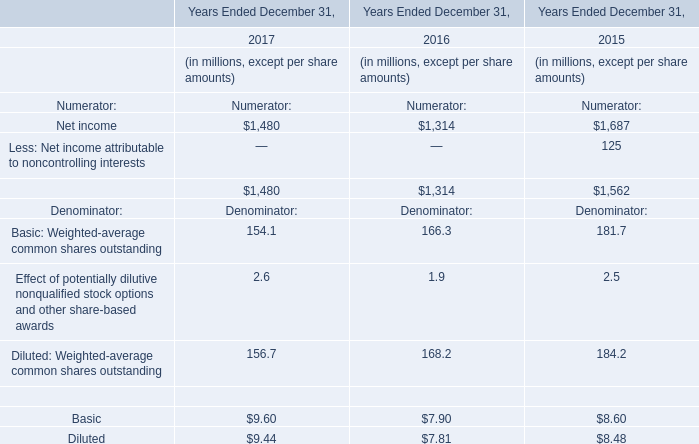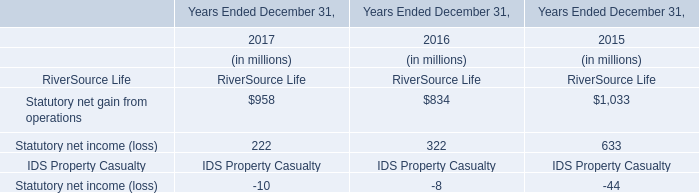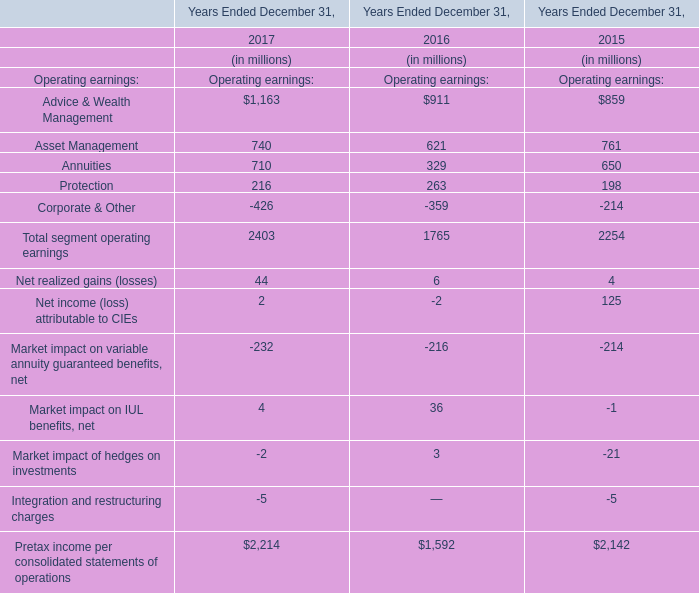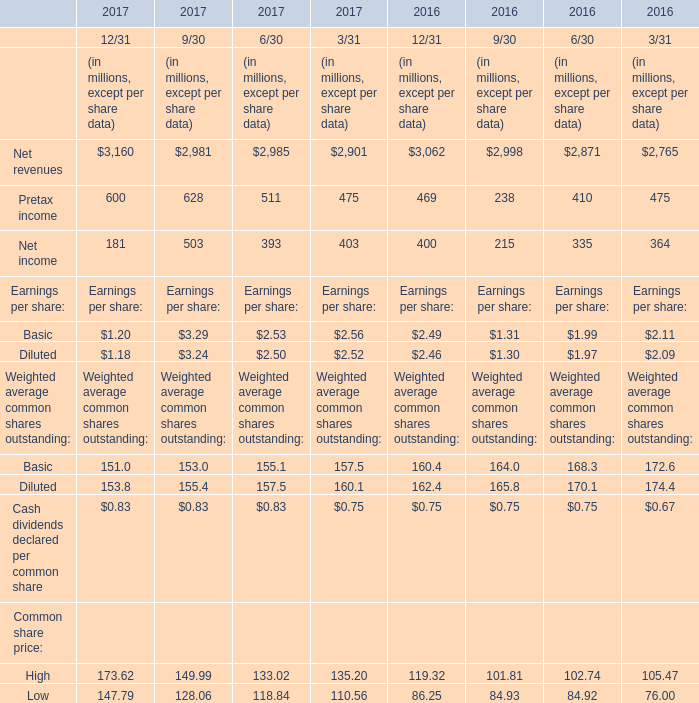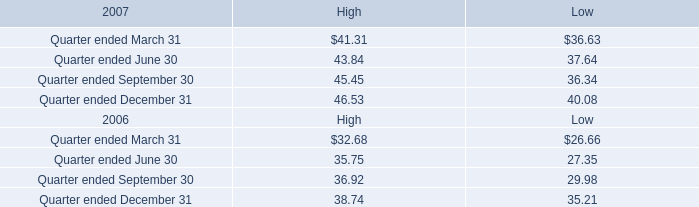What's the difference of Asset Management between 2016 and 2017? (in million) 
Computations: (740 - 621)
Answer: 119.0. 